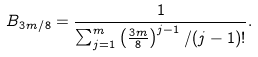Convert formula to latex. <formula><loc_0><loc_0><loc_500><loc_500>B _ { 3 m / 8 } = \frac { 1 } { \sum _ { j = 1 } ^ { m } \left ( \frac { 3 m } { 8 } \right ) ^ { j - 1 } / ( j - 1 ) ! } .</formula> 